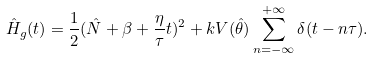<formula> <loc_0><loc_0><loc_500><loc_500>\hat { H } _ { g } ( t ) = \frac { 1 } { 2 } ( \hat { N } + \beta + \frac { \eta } { \tau } t ) ^ { 2 } + k V ( \hat { \theta } ) \sum _ { n = - \infty } ^ { + \infty } \delta ( t - n \tau ) .</formula> 